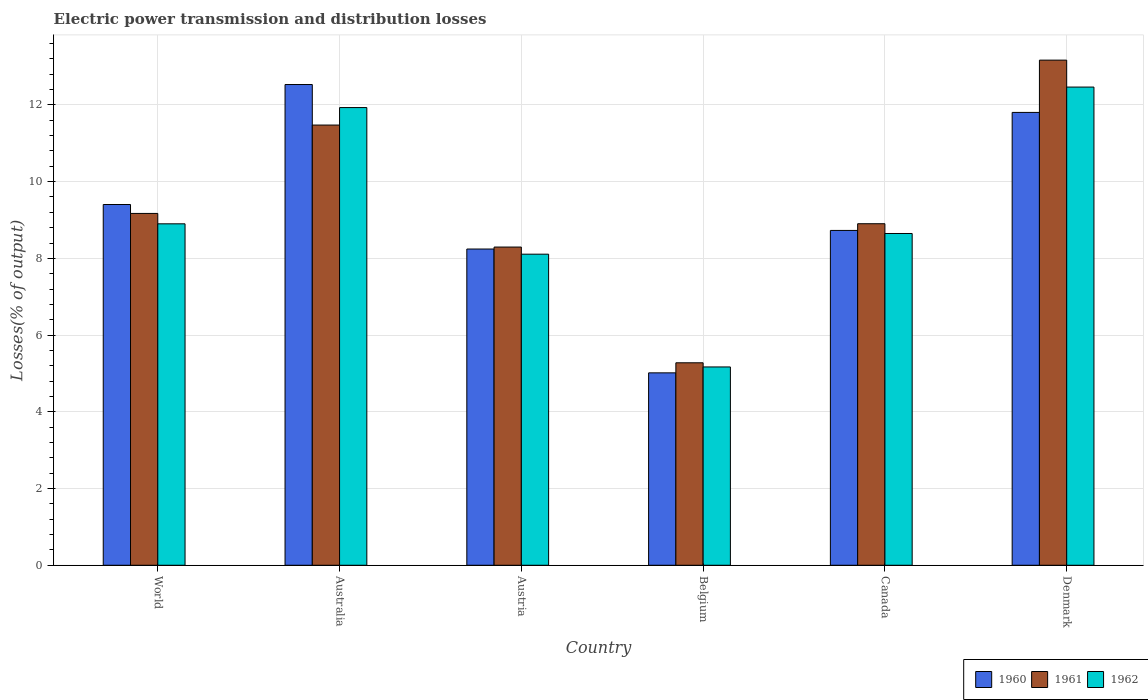How many groups of bars are there?
Make the answer very short. 6. Are the number of bars per tick equal to the number of legend labels?
Offer a terse response. Yes. How many bars are there on the 3rd tick from the left?
Keep it short and to the point. 3. How many bars are there on the 6th tick from the right?
Provide a succinct answer. 3. What is the electric power transmission and distribution losses in 1962 in Denmark?
Provide a short and direct response. 12.47. Across all countries, what is the maximum electric power transmission and distribution losses in 1962?
Your answer should be very brief. 12.47. Across all countries, what is the minimum electric power transmission and distribution losses in 1962?
Keep it short and to the point. 5.17. In which country was the electric power transmission and distribution losses in 1960 maximum?
Your answer should be very brief. Australia. What is the total electric power transmission and distribution losses in 1960 in the graph?
Offer a terse response. 55.73. What is the difference between the electric power transmission and distribution losses in 1960 in Belgium and that in Canada?
Ensure brevity in your answer.  -3.71. What is the difference between the electric power transmission and distribution losses in 1962 in Belgium and the electric power transmission and distribution losses in 1961 in Denmark?
Make the answer very short. -8. What is the average electric power transmission and distribution losses in 1961 per country?
Provide a short and direct response. 9.38. What is the difference between the electric power transmission and distribution losses of/in 1962 and electric power transmission and distribution losses of/in 1961 in Belgium?
Your answer should be compact. -0.11. In how many countries, is the electric power transmission and distribution losses in 1961 greater than 2.4 %?
Keep it short and to the point. 6. What is the ratio of the electric power transmission and distribution losses in 1961 in Australia to that in Belgium?
Provide a short and direct response. 2.17. Is the electric power transmission and distribution losses in 1961 in Belgium less than that in Denmark?
Provide a succinct answer. Yes. Is the difference between the electric power transmission and distribution losses in 1962 in Australia and Austria greater than the difference between the electric power transmission and distribution losses in 1961 in Australia and Austria?
Offer a terse response. Yes. What is the difference between the highest and the second highest electric power transmission and distribution losses in 1960?
Give a very brief answer. -2.4. What is the difference between the highest and the lowest electric power transmission and distribution losses in 1960?
Ensure brevity in your answer.  7.52. In how many countries, is the electric power transmission and distribution losses in 1960 greater than the average electric power transmission and distribution losses in 1960 taken over all countries?
Ensure brevity in your answer.  3. Is the sum of the electric power transmission and distribution losses in 1962 in Australia and Belgium greater than the maximum electric power transmission and distribution losses in 1960 across all countries?
Give a very brief answer. Yes. What does the 2nd bar from the left in Belgium represents?
Your response must be concise. 1961. What does the 1st bar from the right in Canada represents?
Offer a terse response. 1962. Is it the case that in every country, the sum of the electric power transmission and distribution losses in 1961 and electric power transmission and distribution losses in 1960 is greater than the electric power transmission and distribution losses in 1962?
Your answer should be compact. Yes. How many countries are there in the graph?
Offer a very short reply. 6. What is the difference between two consecutive major ticks on the Y-axis?
Provide a succinct answer. 2. Does the graph contain any zero values?
Provide a short and direct response. No. What is the title of the graph?
Your response must be concise. Electric power transmission and distribution losses. What is the label or title of the X-axis?
Provide a succinct answer. Country. What is the label or title of the Y-axis?
Make the answer very short. Losses(% of output). What is the Losses(% of output) of 1960 in World?
Offer a terse response. 9.4. What is the Losses(% of output) in 1961 in World?
Your response must be concise. 9.17. What is the Losses(% of output) in 1962 in World?
Make the answer very short. 8.9. What is the Losses(% of output) of 1960 in Australia?
Your answer should be compact. 12.53. What is the Losses(% of output) in 1961 in Australia?
Your answer should be very brief. 11.48. What is the Losses(% of output) of 1962 in Australia?
Give a very brief answer. 11.93. What is the Losses(% of output) of 1960 in Austria?
Provide a short and direct response. 8.24. What is the Losses(% of output) of 1961 in Austria?
Provide a short and direct response. 8.3. What is the Losses(% of output) in 1962 in Austria?
Offer a terse response. 8.11. What is the Losses(% of output) in 1960 in Belgium?
Provide a succinct answer. 5.02. What is the Losses(% of output) in 1961 in Belgium?
Offer a terse response. 5.28. What is the Losses(% of output) in 1962 in Belgium?
Your answer should be compact. 5.17. What is the Losses(% of output) of 1960 in Canada?
Keep it short and to the point. 8.73. What is the Losses(% of output) of 1961 in Canada?
Your response must be concise. 8.9. What is the Losses(% of output) in 1962 in Canada?
Keep it short and to the point. 8.65. What is the Losses(% of output) of 1960 in Denmark?
Make the answer very short. 11.81. What is the Losses(% of output) in 1961 in Denmark?
Offer a very short reply. 13.17. What is the Losses(% of output) of 1962 in Denmark?
Keep it short and to the point. 12.47. Across all countries, what is the maximum Losses(% of output) in 1960?
Give a very brief answer. 12.53. Across all countries, what is the maximum Losses(% of output) in 1961?
Ensure brevity in your answer.  13.17. Across all countries, what is the maximum Losses(% of output) in 1962?
Offer a very short reply. 12.47. Across all countries, what is the minimum Losses(% of output) of 1960?
Your answer should be very brief. 5.02. Across all countries, what is the minimum Losses(% of output) in 1961?
Provide a short and direct response. 5.28. Across all countries, what is the minimum Losses(% of output) of 1962?
Your response must be concise. 5.17. What is the total Losses(% of output) of 1960 in the graph?
Make the answer very short. 55.73. What is the total Losses(% of output) of 1961 in the graph?
Make the answer very short. 56.29. What is the total Losses(% of output) of 1962 in the graph?
Make the answer very short. 55.22. What is the difference between the Losses(% of output) in 1960 in World and that in Australia?
Provide a short and direct response. -3.13. What is the difference between the Losses(% of output) in 1961 in World and that in Australia?
Keep it short and to the point. -2.3. What is the difference between the Losses(% of output) in 1962 in World and that in Australia?
Make the answer very short. -3.03. What is the difference between the Losses(% of output) of 1960 in World and that in Austria?
Offer a terse response. 1.16. What is the difference between the Losses(% of output) in 1961 in World and that in Austria?
Give a very brief answer. 0.88. What is the difference between the Losses(% of output) of 1962 in World and that in Austria?
Your answer should be very brief. 0.79. What is the difference between the Losses(% of output) in 1960 in World and that in Belgium?
Offer a very short reply. 4.39. What is the difference between the Losses(% of output) of 1961 in World and that in Belgium?
Your answer should be compact. 3.89. What is the difference between the Losses(% of output) in 1962 in World and that in Belgium?
Ensure brevity in your answer.  3.73. What is the difference between the Losses(% of output) of 1960 in World and that in Canada?
Offer a very short reply. 0.68. What is the difference between the Losses(% of output) of 1961 in World and that in Canada?
Provide a short and direct response. 0.27. What is the difference between the Losses(% of output) in 1962 in World and that in Canada?
Ensure brevity in your answer.  0.25. What is the difference between the Losses(% of output) of 1960 in World and that in Denmark?
Your response must be concise. -2.4. What is the difference between the Losses(% of output) in 1961 in World and that in Denmark?
Offer a terse response. -4. What is the difference between the Losses(% of output) of 1962 in World and that in Denmark?
Offer a very short reply. -3.56. What is the difference between the Losses(% of output) of 1960 in Australia and that in Austria?
Your response must be concise. 4.29. What is the difference between the Losses(% of output) of 1961 in Australia and that in Austria?
Your answer should be compact. 3.18. What is the difference between the Losses(% of output) of 1962 in Australia and that in Austria?
Your answer should be compact. 3.82. What is the difference between the Losses(% of output) in 1960 in Australia and that in Belgium?
Give a very brief answer. 7.52. What is the difference between the Losses(% of output) in 1961 in Australia and that in Belgium?
Your answer should be compact. 6.2. What is the difference between the Losses(% of output) in 1962 in Australia and that in Belgium?
Your answer should be compact. 6.76. What is the difference between the Losses(% of output) of 1960 in Australia and that in Canada?
Ensure brevity in your answer.  3.8. What is the difference between the Losses(% of output) in 1961 in Australia and that in Canada?
Keep it short and to the point. 2.57. What is the difference between the Losses(% of output) of 1962 in Australia and that in Canada?
Keep it short and to the point. 3.28. What is the difference between the Losses(% of output) of 1960 in Australia and that in Denmark?
Your response must be concise. 0.73. What is the difference between the Losses(% of output) of 1961 in Australia and that in Denmark?
Your response must be concise. -1.69. What is the difference between the Losses(% of output) of 1962 in Australia and that in Denmark?
Your answer should be very brief. -0.53. What is the difference between the Losses(% of output) in 1960 in Austria and that in Belgium?
Provide a short and direct response. 3.23. What is the difference between the Losses(% of output) of 1961 in Austria and that in Belgium?
Your response must be concise. 3.02. What is the difference between the Losses(% of output) in 1962 in Austria and that in Belgium?
Provide a succinct answer. 2.94. What is the difference between the Losses(% of output) in 1960 in Austria and that in Canada?
Offer a terse response. -0.48. What is the difference between the Losses(% of output) of 1961 in Austria and that in Canada?
Your answer should be compact. -0.61. What is the difference between the Losses(% of output) in 1962 in Austria and that in Canada?
Provide a succinct answer. -0.54. What is the difference between the Losses(% of output) in 1960 in Austria and that in Denmark?
Ensure brevity in your answer.  -3.56. What is the difference between the Losses(% of output) of 1961 in Austria and that in Denmark?
Make the answer very short. -4.87. What is the difference between the Losses(% of output) of 1962 in Austria and that in Denmark?
Your answer should be compact. -4.36. What is the difference between the Losses(% of output) in 1960 in Belgium and that in Canada?
Keep it short and to the point. -3.71. What is the difference between the Losses(% of output) in 1961 in Belgium and that in Canada?
Ensure brevity in your answer.  -3.63. What is the difference between the Losses(% of output) in 1962 in Belgium and that in Canada?
Ensure brevity in your answer.  -3.48. What is the difference between the Losses(% of output) of 1960 in Belgium and that in Denmark?
Offer a very short reply. -6.79. What is the difference between the Losses(% of output) in 1961 in Belgium and that in Denmark?
Give a very brief answer. -7.89. What is the difference between the Losses(% of output) of 1962 in Belgium and that in Denmark?
Offer a terse response. -7.3. What is the difference between the Losses(% of output) of 1960 in Canada and that in Denmark?
Ensure brevity in your answer.  -3.08. What is the difference between the Losses(% of output) of 1961 in Canada and that in Denmark?
Your answer should be very brief. -4.26. What is the difference between the Losses(% of output) of 1962 in Canada and that in Denmark?
Ensure brevity in your answer.  -3.82. What is the difference between the Losses(% of output) of 1960 in World and the Losses(% of output) of 1961 in Australia?
Give a very brief answer. -2.07. What is the difference between the Losses(% of output) in 1960 in World and the Losses(% of output) in 1962 in Australia?
Provide a succinct answer. -2.53. What is the difference between the Losses(% of output) in 1961 in World and the Losses(% of output) in 1962 in Australia?
Your response must be concise. -2.76. What is the difference between the Losses(% of output) in 1960 in World and the Losses(% of output) in 1961 in Austria?
Keep it short and to the point. 1.11. What is the difference between the Losses(% of output) of 1960 in World and the Losses(% of output) of 1962 in Austria?
Provide a short and direct response. 1.29. What is the difference between the Losses(% of output) of 1961 in World and the Losses(% of output) of 1962 in Austria?
Your response must be concise. 1.06. What is the difference between the Losses(% of output) of 1960 in World and the Losses(% of output) of 1961 in Belgium?
Your answer should be very brief. 4.13. What is the difference between the Losses(% of output) of 1960 in World and the Losses(% of output) of 1962 in Belgium?
Make the answer very short. 4.23. What is the difference between the Losses(% of output) in 1961 in World and the Losses(% of output) in 1962 in Belgium?
Provide a succinct answer. 4. What is the difference between the Losses(% of output) in 1960 in World and the Losses(% of output) in 1961 in Canada?
Keep it short and to the point. 0.5. What is the difference between the Losses(% of output) in 1960 in World and the Losses(% of output) in 1962 in Canada?
Keep it short and to the point. 0.76. What is the difference between the Losses(% of output) in 1961 in World and the Losses(% of output) in 1962 in Canada?
Your answer should be very brief. 0.52. What is the difference between the Losses(% of output) of 1960 in World and the Losses(% of output) of 1961 in Denmark?
Keep it short and to the point. -3.76. What is the difference between the Losses(% of output) in 1960 in World and the Losses(% of output) in 1962 in Denmark?
Your response must be concise. -3.06. What is the difference between the Losses(% of output) of 1961 in World and the Losses(% of output) of 1962 in Denmark?
Give a very brief answer. -3.29. What is the difference between the Losses(% of output) of 1960 in Australia and the Losses(% of output) of 1961 in Austria?
Ensure brevity in your answer.  4.24. What is the difference between the Losses(% of output) of 1960 in Australia and the Losses(% of output) of 1962 in Austria?
Your answer should be compact. 4.42. What is the difference between the Losses(% of output) in 1961 in Australia and the Losses(% of output) in 1962 in Austria?
Your response must be concise. 3.37. What is the difference between the Losses(% of output) in 1960 in Australia and the Losses(% of output) in 1961 in Belgium?
Give a very brief answer. 7.25. What is the difference between the Losses(% of output) of 1960 in Australia and the Losses(% of output) of 1962 in Belgium?
Keep it short and to the point. 7.36. What is the difference between the Losses(% of output) in 1961 in Australia and the Losses(% of output) in 1962 in Belgium?
Give a very brief answer. 6.31. What is the difference between the Losses(% of output) in 1960 in Australia and the Losses(% of output) in 1961 in Canada?
Make the answer very short. 3.63. What is the difference between the Losses(% of output) of 1960 in Australia and the Losses(% of output) of 1962 in Canada?
Your answer should be very brief. 3.88. What is the difference between the Losses(% of output) in 1961 in Australia and the Losses(% of output) in 1962 in Canada?
Your answer should be compact. 2.83. What is the difference between the Losses(% of output) of 1960 in Australia and the Losses(% of output) of 1961 in Denmark?
Provide a short and direct response. -0.64. What is the difference between the Losses(% of output) in 1960 in Australia and the Losses(% of output) in 1962 in Denmark?
Provide a short and direct response. 0.07. What is the difference between the Losses(% of output) of 1961 in Australia and the Losses(% of output) of 1962 in Denmark?
Offer a terse response. -0.99. What is the difference between the Losses(% of output) of 1960 in Austria and the Losses(% of output) of 1961 in Belgium?
Your response must be concise. 2.97. What is the difference between the Losses(% of output) in 1960 in Austria and the Losses(% of output) in 1962 in Belgium?
Your response must be concise. 3.07. What is the difference between the Losses(% of output) of 1961 in Austria and the Losses(% of output) of 1962 in Belgium?
Provide a succinct answer. 3.13. What is the difference between the Losses(% of output) in 1960 in Austria and the Losses(% of output) in 1961 in Canada?
Your answer should be very brief. -0.66. What is the difference between the Losses(% of output) of 1960 in Austria and the Losses(% of output) of 1962 in Canada?
Offer a very short reply. -0.4. What is the difference between the Losses(% of output) of 1961 in Austria and the Losses(% of output) of 1962 in Canada?
Your answer should be compact. -0.35. What is the difference between the Losses(% of output) of 1960 in Austria and the Losses(% of output) of 1961 in Denmark?
Provide a short and direct response. -4.92. What is the difference between the Losses(% of output) in 1960 in Austria and the Losses(% of output) in 1962 in Denmark?
Give a very brief answer. -4.22. What is the difference between the Losses(% of output) in 1961 in Austria and the Losses(% of output) in 1962 in Denmark?
Your response must be concise. -4.17. What is the difference between the Losses(% of output) of 1960 in Belgium and the Losses(% of output) of 1961 in Canada?
Ensure brevity in your answer.  -3.89. What is the difference between the Losses(% of output) of 1960 in Belgium and the Losses(% of output) of 1962 in Canada?
Make the answer very short. -3.63. What is the difference between the Losses(% of output) in 1961 in Belgium and the Losses(% of output) in 1962 in Canada?
Give a very brief answer. -3.37. What is the difference between the Losses(% of output) in 1960 in Belgium and the Losses(% of output) in 1961 in Denmark?
Your response must be concise. -8.15. What is the difference between the Losses(% of output) of 1960 in Belgium and the Losses(% of output) of 1962 in Denmark?
Provide a short and direct response. -7.45. What is the difference between the Losses(% of output) in 1961 in Belgium and the Losses(% of output) in 1962 in Denmark?
Your answer should be compact. -7.19. What is the difference between the Losses(% of output) of 1960 in Canada and the Losses(% of output) of 1961 in Denmark?
Provide a short and direct response. -4.44. What is the difference between the Losses(% of output) in 1960 in Canada and the Losses(% of output) in 1962 in Denmark?
Ensure brevity in your answer.  -3.74. What is the difference between the Losses(% of output) of 1961 in Canada and the Losses(% of output) of 1962 in Denmark?
Offer a terse response. -3.56. What is the average Losses(% of output) of 1960 per country?
Your answer should be very brief. 9.29. What is the average Losses(% of output) of 1961 per country?
Keep it short and to the point. 9.38. What is the average Losses(% of output) of 1962 per country?
Offer a very short reply. 9.2. What is the difference between the Losses(% of output) of 1960 and Losses(% of output) of 1961 in World?
Your answer should be very brief. 0.23. What is the difference between the Losses(% of output) in 1960 and Losses(% of output) in 1962 in World?
Your answer should be very brief. 0.5. What is the difference between the Losses(% of output) in 1961 and Losses(% of output) in 1962 in World?
Provide a succinct answer. 0.27. What is the difference between the Losses(% of output) in 1960 and Losses(% of output) in 1961 in Australia?
Provide a short and direct response. 1.06. What is the difference between the Losses(% of output) of 1960 and Losses(% of output) of 1962 in Australia?
Make the answer very short. 0.6. What is the difference between the Losses(% of output) in 1961 and Losses(% of output) in 1962 in Australia?
Offer a terse response. -0.46. What is the difference between the Losses(% of output) in 1960 and Losses(% of output) in 1961 in Austria?
Ensure brevity in your answer.  -0.05. What is the difference between the Losses(% of output) in 1960 and Losses(% of output) in 1962 in Austria?
Ensure brevity in your answer.  0.13. What is the difference between the Losses(% of output) in 1961 and Losses(% of output) in 1962 in Austria?
Keep it short and to the point. 0.19. What is the difference between the Losses(% of output) in 1960 and Losses(% of output) in 1961 in Belgium?
Provide a succinct answer. -0.26. What is the difference between the Losses(% of output) in 1960 and Losses(% of output) in 1962 in Belgium?
Your answer should be compact. -0.15. What is the difference between the Losses(% of output) of 1961 and Losses(% of output) of 1962 in Belgium?
Offer a very short reply. 0.11. What is the difference between the Losses(% of output) in 1960 and Losses(% of output) in 1961 in Canada?
Your answer should be compact. -0.17. What is the difference between the Losses(% of output) of 1961 and Losses(% of output) of 1962 in Canada?
Provide a succinct answer. 0.25. What is the difference between the Losses(% of output) in 1960 and Losses(% of output) in 1961 in Denmark?
Ensure brevity in your answer.  -1.36. What is the difference between the Losses(% of output) in 1960 and Losses(% of output) in 1962 in Denmark?
Offer a very short reply. -0.66. What is the difference between the Losses(% of output) in 1961 and Losses(% of output) in 1962 in Denmark?
Your answer should be very brief. 0.7. What is the ratio of the Losses(% of output) in 1960 in World to that in Australia?
Provide a short and direct response. 0.75. What is the ratio of the Losses(% of output) in 1961 in World to that in Australia?
Offer a terse response. 0.8. What is the ratio of the Losses(% of output) in 1962 in World to that in Australia?
Your response must be concise. 0.75. What is the ratio of the Losses(% of output) of 1960 in World to that in Austria?
Provide a succinct answer. 1.14. What is the ratio of the Losses(% of output) in 1961 in World to that in Austria?
Provide a short and direct response. 1.11. What is the ratio of the Losses(% of output) of 1962 in World to that in Austria?
Provide a succinct answer. 1.1. What is the ratio of the Losses(% of output) of 1960 in World to that in Belgium?
Keep it short and to the point. 1.87. What is the ratio of the Losses(% of output) in 1961 in World to that in Belgium?
Provide a short and direct response. 1.74. What is the ratio of the Losses(% of output) of 1962 in World to that in Belgium?
Make the answer very short. 1.72. What is the ratio of the Losses(% of output) of 1960 in World to that in Canada?
Make the answer very short. 1.08. What is the ratio of the Losses(% of output) in 1961 in World to that in Canada?
Provide a short and direct response. 1.03. What is the ratio of the Losses(% of output) in 1962 in World to that in Canada?
Make the answer very short. 1.03. What is the ratio of the Losses(% of output) in 1960 in World to that in Denmark?
Offer a terse response. 0.8. What is the ratio of the Losses(% of output) of 1961 in World to that in Denmark?
Provide a succinct answer. 0.7. What is the ratio of the Losses(% of output) in 1962 in World to that in Denmark?
Keep it short and to the point. 0.71. What is the ratio of the Losses(% of output) of 1960 in Australia to that in Austria?
Offer a terse response. 1.52. What is the ratio of the Losses(% of output) of 1961 in Australia to that in Austria?
Ensure brevity in your answer.  1.38. What is the ratio of the Losses(% of output) of 1962 in Australia to that in Austria?
Ensure brevity in your answer.  1.47. What is the ratio of the Losses(% of output) of 1960 in Australia to that in Belgium?
Ensure brevity in your answer.  2.5. What is the ratio of the Losses(% of output) of 1961 in Australia to that in Belgium?
Make the answer very short. 2.17. What is the ratio of the Losses(% of output) of 1962 in Australia to that in Belgium?
Provide a succinct answer. 2.31. What is the ratio of the Losses(% of output) in 1960 in Australia to that in Canada?
Give a very brief answer. 1.44. What is the ratio of the Losses(% of output) in 1961 in Australia to that in Canada?
Make the answer very short. 1.29. What is the ratio of the Losses(% of output) of 1962 in Australia to that in Canada?
Ensure brevity in your answer.  1.38. What is the ratio of the Losses(% of output) in 1960 in Australia to that in Denmark?
Provide a short and direct response. 1.06. What is the ratio of the Losses(% of output) of 1961 in Australia to that in Denmark?
Your response must be concise. 0.87. What is the ratio of the Losses(% of output) of 1962 in Australia to that in Denmark?
Keep it short and to the point. 0.96. What is the ratio of the Losses(% of output) of 1960 in Austria to that in Belgium?
Your answer should be compact. 1.64. What is the ratio of the Losses(% of output) of 1961 in Austria to that in Belgium?
Make the answer very short. 1.57. What is the ratio of the Losses(% of output) in 1962 in Austria to that in Belgium?
Your response must be concise. 1.57. What is the ratio of the Losses(% of output) of 1960 in Austria to that in Canada?
Ensure brevity in your answer.  0.94. What is the ratio of the Losses(% of output) of 1961 in Austria to that in Canada?
Provide a short and direct response. 0.93. What is the ratio of the Losses(% of output) in 1962 in Austria to that in Canada?
Offer a very short reply. 0.94. What is the ratio of the Losses(% of output) of 1960 in Austria to that in Denmark?
Make the answer very short. 0.7. What is the ratio of the Losses(% of output) in 1961 in Austria to that in Denmark?
Offer a terse response. 0.63. What is the ratio of the Losses(% of output) in 1962 in Austria to that in Denmark?
Provide a succinct answer. 0.65. What is the ratio of the Losses(% of output) in 1960 in Belgium to that in Canada?
Offer a terse response. 0.57. What is the ratio of the Losses(% of output) of 1961 in Belgium to that in Canada?
Provide a succinct answer. 0.59. What is the ratio of the Losses(% of output) of 1962 in Belgium to that in Canada?
Make the answer very short. 0.6. What is the ratio of the Losses(% of output) of 1960 in Belgium to that in Denmark?
Ensure brevity in your answer.  0.42. What is the ratio of the Losses(% of output) of 1961 in Belgium to that in Denmark?
Give a very brief answer. 0.4. What is the ratio of the Losses(% of output) of 1962 in Belgium to that in Denmark?
Make the answer very short. 0.41. What is the ratio of the Losses(% of output) of 1960 in Canada to that in Denmark?
Provide a short and direct response. 0.74. What is the ratio of the Losses(% of output) of 1961 in Canada to that in Denmark?
Your response must be concise. 0.68. What is the ratio of the Losses(% of output) in 1962 in Canada to that in Denmark?
Keep it short and to the point. 0.69. What is the difference between the highest and the second highest Losses(% of output) in 1960?
Your answer should be compact. 0.73. What is the difference between the highest and the second highest Losses(% of output) in 1961?
Provide a succinct answer. 1.69. What is the difference between the highest and the second highest Losses(% of output) in 1962?
Your answer should be compact. 0.53. What is the difference between the highest and the lowest Losses(% of output) of 1960?
Offer a terse response. 7.52. What is the difference between the highest and the lowest Losses(% of output) in 1961?
Your answer should be very brief. 7.89. What is the difference between the highest and the lowest Losses(% of output) of 1962?
Ensure brevity in your answer.  7.3. 